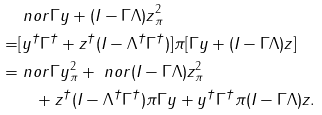Convert formula to latex. <formula><loc_0><loc_0><loc_500><loc_500>& \ n o r { \Gamma { y } + ( I - \Gamma \Lambda ) { z } } ^ { 2 } _ { \pi } \\ = & [ { y } ^ { \dag } \Gamma ^ { \dag } + { z } ^ { \dag } ( I - \Lambda ^ { \dag } \Gamma ^ { \dag } ) ] \pi [ \Gamma { y } + ( I - \Gamma \Lambda ) { z } ] \\ = & \ n o r { \Gamma { y } } _ { \pi } ^ { 2 } + \ n o r { ( I - \Gamma \Lambda ) { z } } _ { \pi } ^ { 2 } \\ & \quad + { z } ^ { \dag } ( I - \Lambda ^ { \dag } \Gamma ^ { \dag } ) \pi \Gamma { y } + { y } ^ { \dag } \Gamma ^ { \dag } \pi ( I - \Gamma \Lambda ) { z } .</formula> 